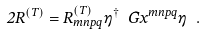<formula> <loc_0><loc_0><loc_500><loc_500>2 R ^ { ( T ) } = R ^ { ( T ) } _ { m n p q } \eta ^ { \dagger } \ G x ^ { m n p q } \eta \ .</formula> 